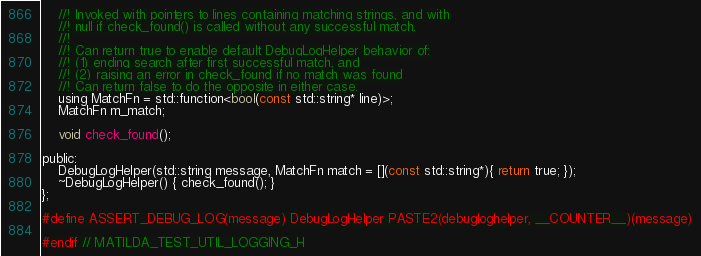<code> <loc_0><loc_0><loc_500><loc_500><_C_>    //! Invoked with pointers to lines containing matching strings, and with
    //! null if check_found() is called without any successful match.
    //!
    //! Can return true to enable default DebugLogHelper behavior of:
    //! (1) ending search after first successful match, and
    //! (2) raising an error in check_found if no match was found
    //! Can return false to do the opposite in either case.
    using MatchFn = std::function<bool(const std::string* line)>;
    MatchFn m_match;

    void check_found();

public:
    DebugLogHelper(std::string message, MatchFn match = [](const std::string*){ return true; });
    ~DebugLogHelper() { check_found(); }
};

#define ASSERT_DEBUG_LOG(message) DebugLogHelper PASTE2(debugloghelper, __COUNTER__)(message)

#endif // MATILDA_TEST_UTIL_LOGGING_H
</code> 